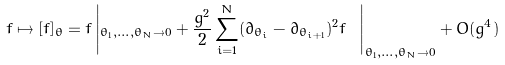<formula> <loc_0><loc_0><loc_500><loc_500>f \mapsto [ f ] _ { \theta } = f \left | _ { \theta _ { 1 } , \dots , \theta _ { N } \rightarrow 0 } + \frac { g ^ { 2 } } { 2 } \sum _ { i = 1 } ^ { N } ( \partial _ { \theta _ { i } } - \partial _ { \theta _ { i + 1 } } ) ^ { 2 } f \ \right | _ { \theta _ { 1 } , \dots , \theta _ { N } \rightarrow 0 } + O ( g ^ { 4 } )</formula> 